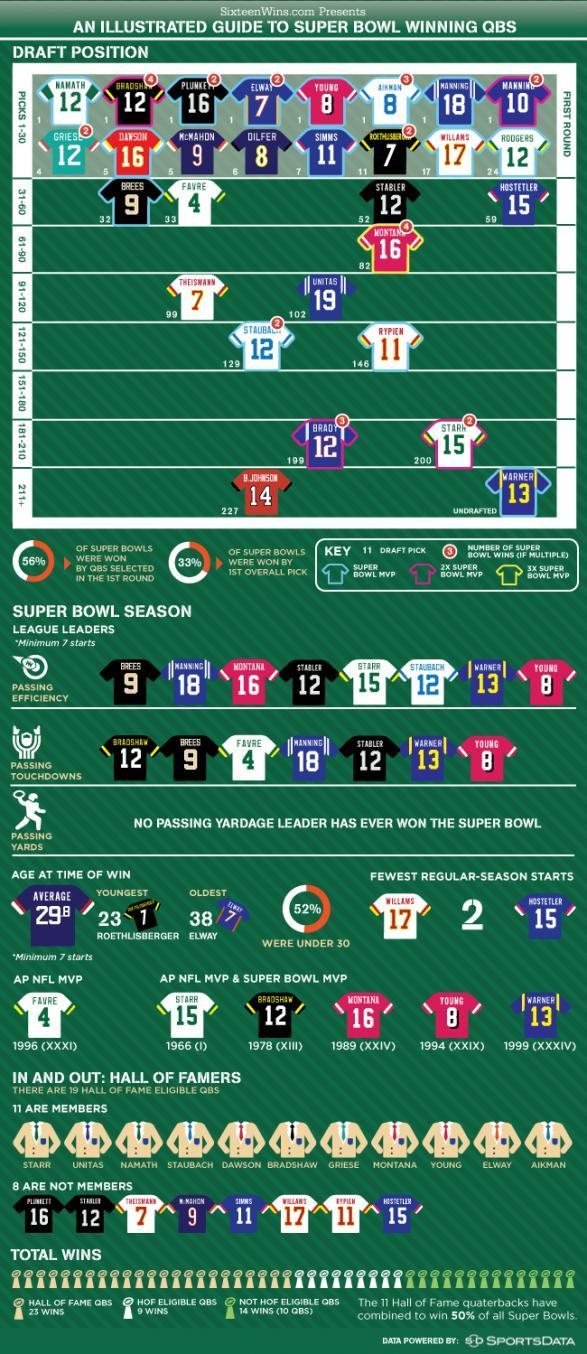What is Dawson's jersey colour, red or black
Answer the question with a short phrase. red Who has had the fewest regular season starts Williams, Hostetler What is the average age at the time of win 29.8 Who are in picks 181-210 brady, stark Who is undrafted Warner Which was the youngest age at the time of win 23 What is the jersey number of Young 8 Which was the oldest age at the time of win 38 